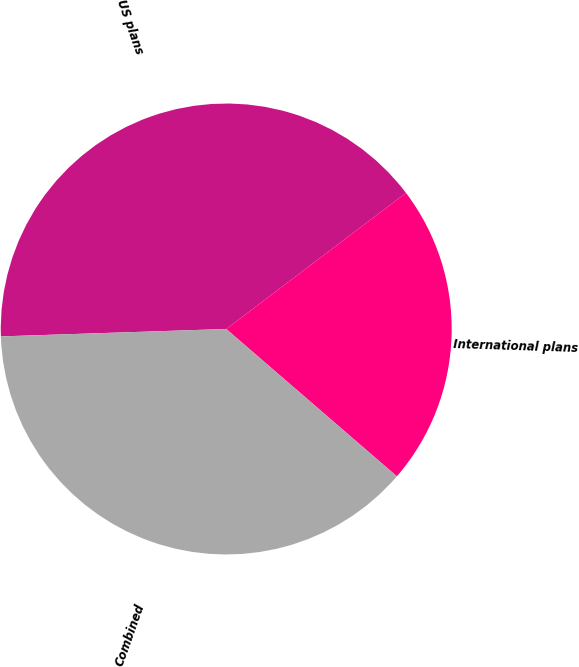<chart> <loc_0><loc_0><loc_500><loc_500><pie_chart><fcel>US plans<fcel>International plans<fcel>Combined<nl><fcel>40.21%<fcel>21.65%<fcel>38.14%<nl></chart> 